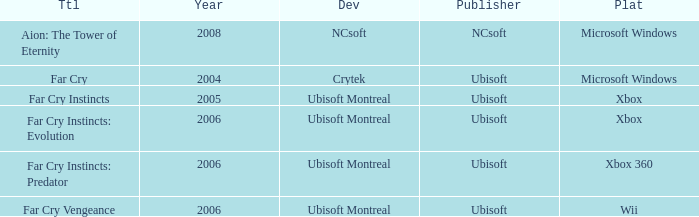Which publisher is associated with the game far cry? Ubisoft. 